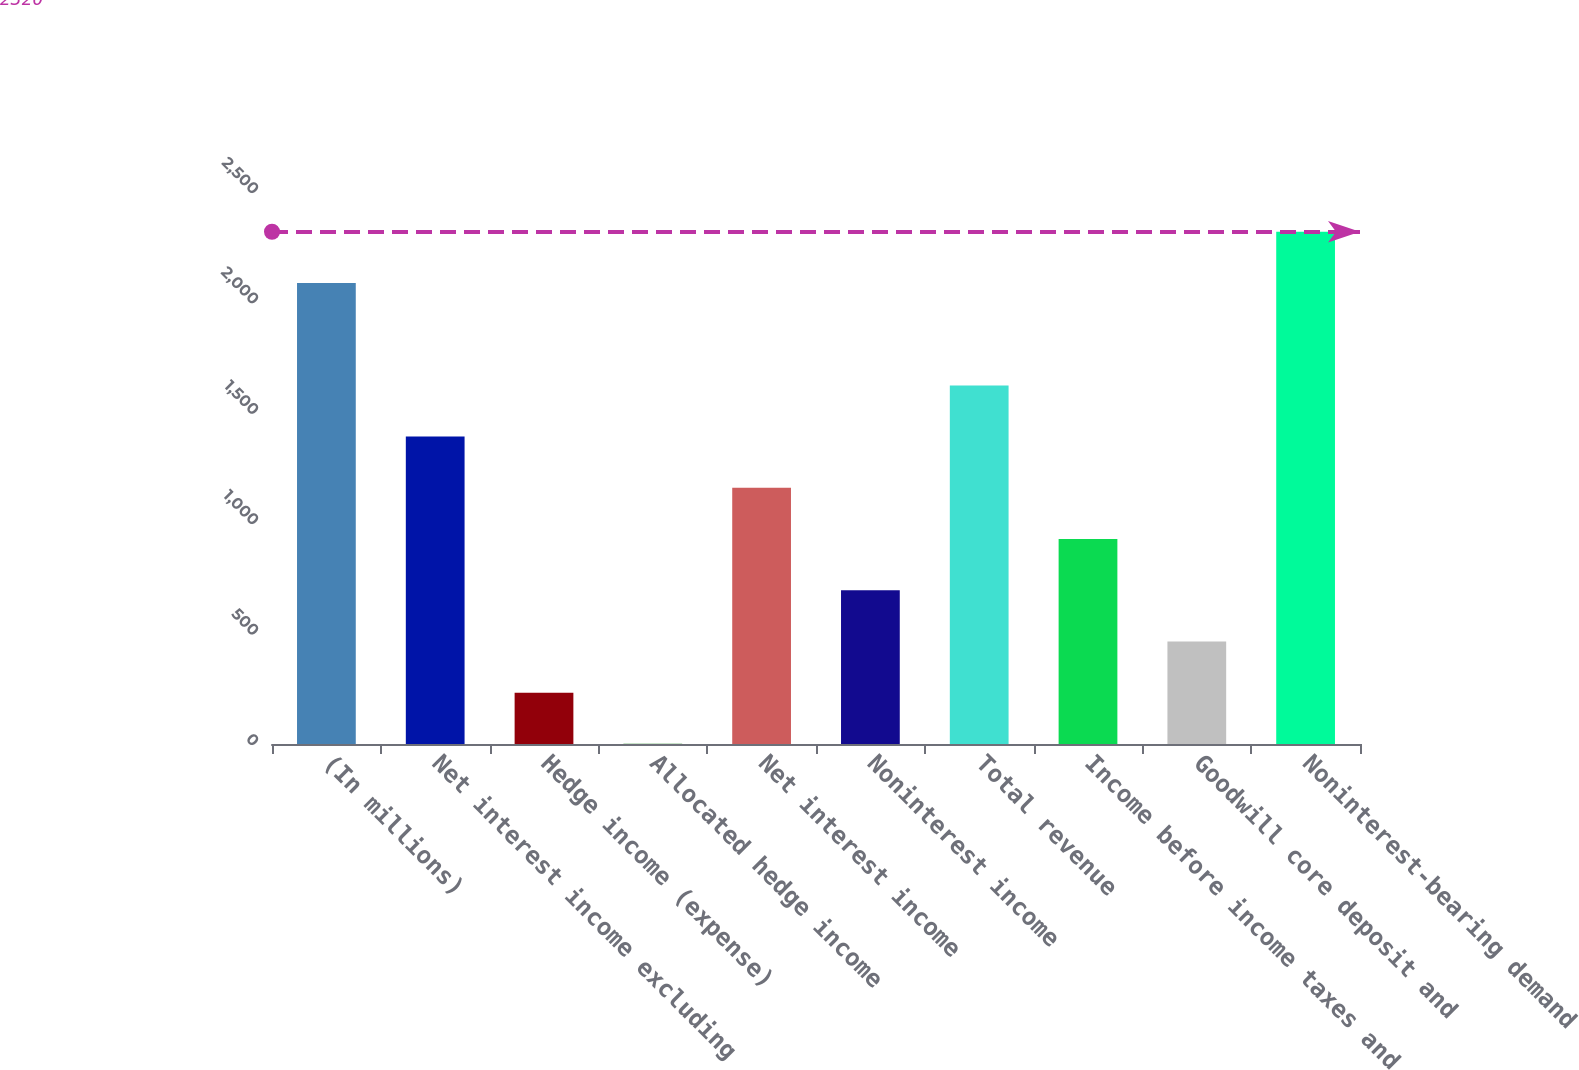Convert chart. <chart><loc_0><loc_0><loc_500><loc_500><bar_chart><fcel>(In millions)<fcel>Net interest income excluding<fcel>Hedge income (expense)<fcel>Allocated hedge income<fcel>Net interest income<fcel>Noninterest income<fcel>Total revenue<fcel>Income before income taxes and<fcel>Goodwill core deposit and<fcel>Noninterest-bearing demand<nl><fcel>2088.06<fcel>1392.24<fcel>232.54<fcel>0.6<fcel>1160.3<fcel>696.42<fcel>1624.18<fcel>928.36<fcel>464.48<fcel>2320<nl></chart> 